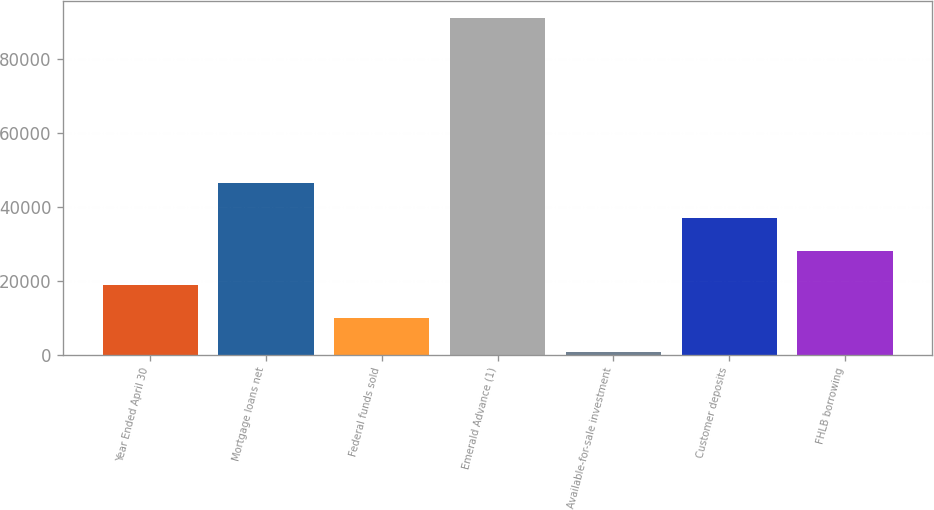Convert chart. <chart><loc_0><loc_0><loc_500><loc_500><bar_chart><fcel>Year Ended April 30<fcel>Mortgage loans net<fcel>Federal funds sold<fcel>Emerald Advance (1)<fcel>Available-for-sale investment<fcel>Customer deposits<fcel>FHLB borrowing<nl><fcel>18836.6<fcel>46396<fcel>9813.8<fcel>91019<fcel>791<fcel>36882.2<fcel>27859.4<nl></chart> 